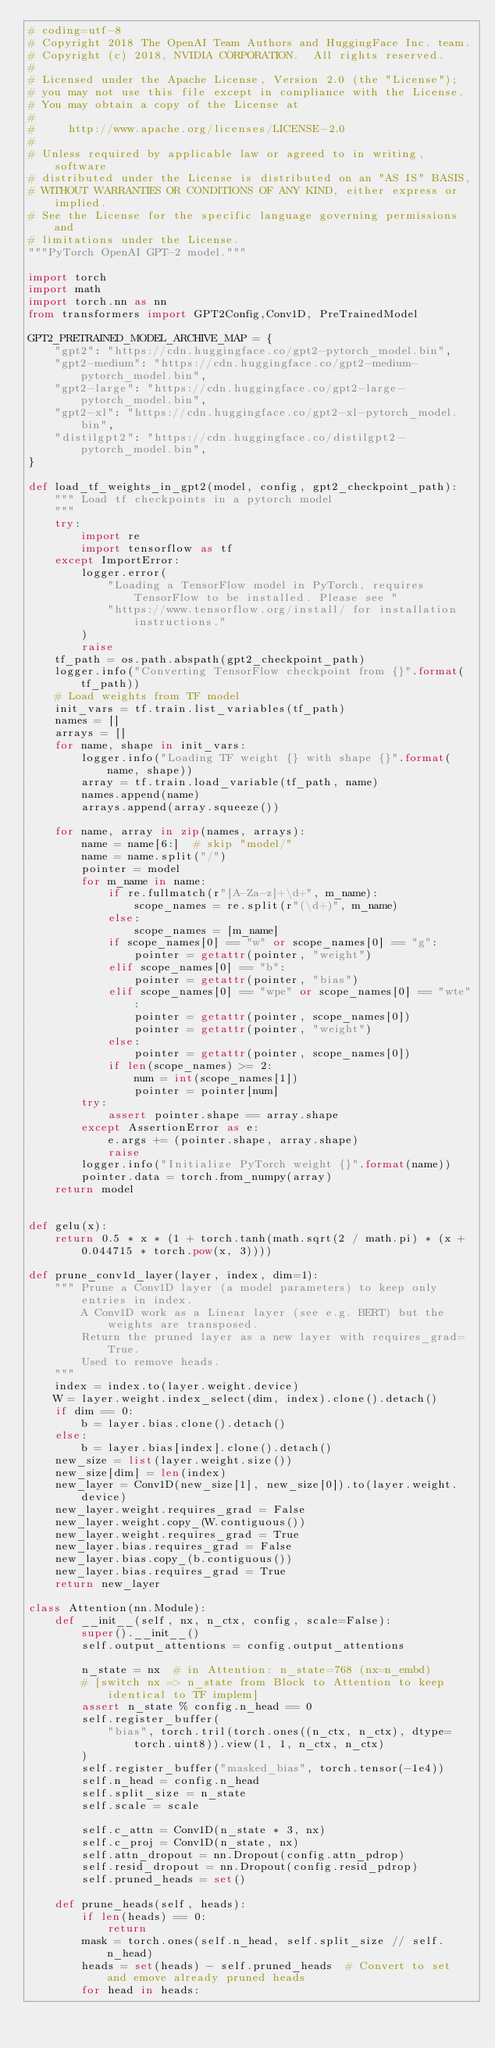Convert code to text. <code><loc_0><loc_0><loc_500><loc_500><_Python_># coding=utf-8
# Copyright 2018 The OpenAI Team Authors and HuggingFace Inc. team.
# Copyright (c) 2018, NVIDIA CORPORATION.  All rights reserved.
#
# Licensed under the Apache License, Version 2.0 (the "License");
# you may not use this file except in compliance with the License.
# You may obtain a copy of the License at
#
#     http://www.apache.org/licenses/LICENSE-2.0
#
# Unless required by applicable law or agreed to in writing, software
# distributed under the License is distributed on an "AS IS" BASIS,
# WITHOUT WARRANTIES OR CONDITIONS OF ANY KIND, either express or implied.
# See the License for the specific language governing permissions and
# limitations under the License.
"""PyTorch OpenAI GPT-2 model."""

import torch
import math
import torch.nn as nn
from transformers import GPT2Config,Conv1D, PreTrainedModel

GPT2_PRETRAINED_MODEL_ARCHIVE_MAP = {
    "gpt2": "https://cdn.huggingface.co/gpt2-pytorch_model.bin",
    "gpt2-medium": "https://cdn.huggingface.co/gpt2-medium-pytorch_model.bin",
    "gpt2-large": "https://cdn.huggingface.co/gpt2-large-pytorch_model.bin",
    "gpt2-xl": "https://cdn.huggingface.co/gpt2-xl-pytorch_model.bin",
    "distilgpt2": "https://cdn.huggingface.co/distilgpt2-pytorch_model.bin",
}

def load_tf_weights_in_gpt2(model, config, gpt2_checkpoint_path):
    """ Load tf checkpoints in a pytorch model
    """
    try:
        import re
        import tensorflow as tf
    except ImportError:
        logger.error(
            "Loading a TensorFlow model in PyTorch, requires TensorFlow to be installed. Please see "
            "https://www.tensorflow.org/install/ for installation instructions."
        )
        raise
    tf_path = os.path.abspath(gpt2_checkpoint_path)
    logger.info("Converting TensorFlow checkpoint from {}".format(tf_path))
    # Load weights from TF model
    init_vars = tf.train.list_variables(tf_path)
    names = []
    arrays = []
    for name, shape in init_vars:
        logger.info("Loading TF weight {} with shape {}".format(name, shape))
        array = tf.train.load_variable(tf_path, name)
        names.append(name)
        arrays.append(array.squeeze())

    for name, array in zip(names, arrays):
        name = name[6:]  # skip "model/"
        name = name.split("/")
        pointer = model
        for m_name in name:
            if re.fullmatch(r"[A-Za-z]+\d+", m_name):
                scope_names = re.split(r"(\d+)", m_name)
            else:
                scope_names = [m_name]
            if scope_names[0] == "w" or scope_names[0] == "g":
                pointer = getattr(pointer, "weight")
            elif scope_names[0] == "b":
                pointer = getattr(pointer, "bias")
            elif scope_names[0] == "wpe" or scope_names[0] == "wte":
                pointer = getattr(pointer, scope_names[0])
                pointer = getattr(pointer, "weight")
            else:
                pointer = getattr(pointer, scope_names[0])
            if len(scope_names) >= 2:
                num = int(scope_names[1])
                pointer = pointer[num]
        try:
            assert pointer.shape == array.shape
        except AssertionError as e:
            e.args += (pointer.shape, array.shape)
            raise
        logger.info("Initialize PyTorch weight {}".format(name))
        pointer.data = torch.from_numpy(array)
    return model


def gelu(x):
    return 0.5 * x * (1 + torch.tanh(math.sqrt(2 / math.pi) * (x + 0.044715 * torch.pow(x, 3))))

def prune_conv1d_layer(layer, index, dim=1):
    """ Prune a Conv1D layer (a model parameters) to keep only entries in index.
        A Conv1D work as a Linear layer (see e.g. BERT) but the weights are transposed.
        Return the pruned layer as a new layer with requires_grad=True.
        Used to remove heads.
    """
    index = index.to(layer.weight.device)
    W = layer.weight.index_select(dim, index).clone().detach()
    if dim == 0:
        b = layer.bias.clone().detach()
    else:
        b = layer.bias[index].clone().detach()
    new_size = list(layer.weight.size())
    new_size[dim] = len(index)
    new_layer = Conv1D(new_size[1], new_size[0]).to(layer.weight.device)
    new_layer.weight.requires_grad = False
    new_layer.weight.copy_(W.contiguous())
    new_layer.weight.requires_grad = True
    new_layer.bias.requires_grad = False
    new_layer.bias.copy_(b.contiguous())
    new_layer.bias.requires_grad = True
    return new_layer

class Attention(nn.Module):
    def __init__(self, nx, n_ctx, config, scale=False):
        super().__init__()
        self.output_attentions = config.output_attentions

        n_state = nx  # in Attention: n_state=768 (nx=n_embd)
        # [switch nx => n_state from Block to Attention to keep identical to TF implem]
        assert n_state % config.n_head == 0
        self.register_buffer(
            "bias", torch.tril(torch.ones((n_ctx, n_ctx), dtype=torch.uint8)).view(1, 1, n_ctx, n_ctx)
        )
        self.register_buffer("masked_bias", torch.tensor(-1e4))
        self.n_head = config.n_head
        self.split_size = n_state
        self.scale = scale

        self.c_attn = Conv1D(n_state * 3, nx)
        self.c_proj = Conv1D(n_state, nx)
        self.attn_dropout = nn.Dropout(config.attn_pdrop)
        self.resid_dropout = nn.Dropout(config.resid_pdrop)
        self.pruned_heads = set()

    def prune_heads(self, heads):
        if len(heads) == 0:
            return
        mask = torch.ones(self.n_head, self.split_size // self.n_head)
        heads = set(heads) - self.pruned_heads  # Convert to set and emove already pruned heads
        for head in heads:</code> 